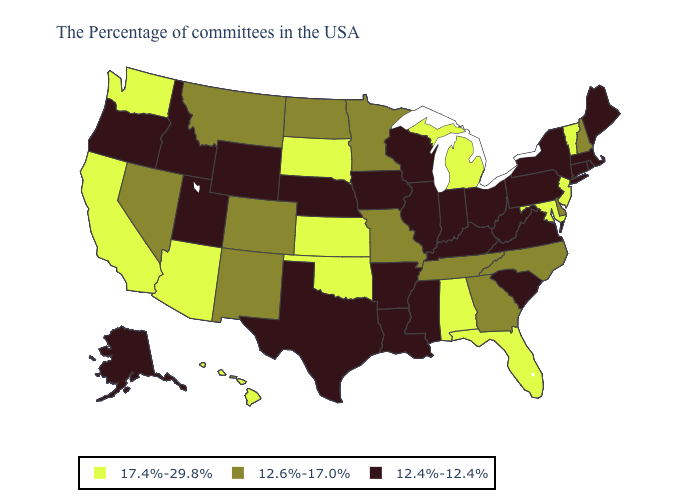Among the states that border Kansas , which have the highest value?
Give a very brief answer. Oklahoma. What is the lowest value in the USA?
Short answer required. 12.4%-12.4%. What is the value of Colorado?
Be succinct. 12.6%-17.0%. Does California have the lowest value in the West?
Answer briefly. No. Does North Carolina have the lowest value in the South?
Be succinct. No. Among the states that border New York , does Connecticut have the highest value?
Keep it brief. No. Among the states that border Texas , which have the highest value?
Keep it brief. Oklahoma. How many symbols are there in the legend?
Concise answer only. 3. Does Pennsylvania have the highest value in the USA?
Short answer required. No. What is the value of Washington?
Be succinct. 17.4%-29.8%. Does Delaware have the same value as Georgia?
Be succinct. Yes. What is the value of Rhode Island?
Write a very short answer. 12.4%-12.4%. Name the states that have a value in the range 17.4%-29.8%?
Keep it brief. Vermont, New Jersey, Maryland, Florida, Michigan, Alabama, Kansas, Oklahoma, South Dakota, Arizona, California, Washington, Hawaii. What is the lowest value in the USA?
Be succinct. 12.4%-12.4%. How many symbols are there in the legend?
Quick response, please. 3. 